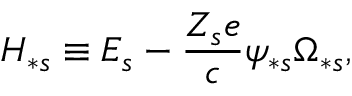<formula> <loc_0><loc_0><loc_500><loc_500>H _ { \ast s } \equiv E _ { s } - \frac { Z _ { s } e } { c } \psi _ { \ast s } \Omega _ { \ast s } ,</formula> 